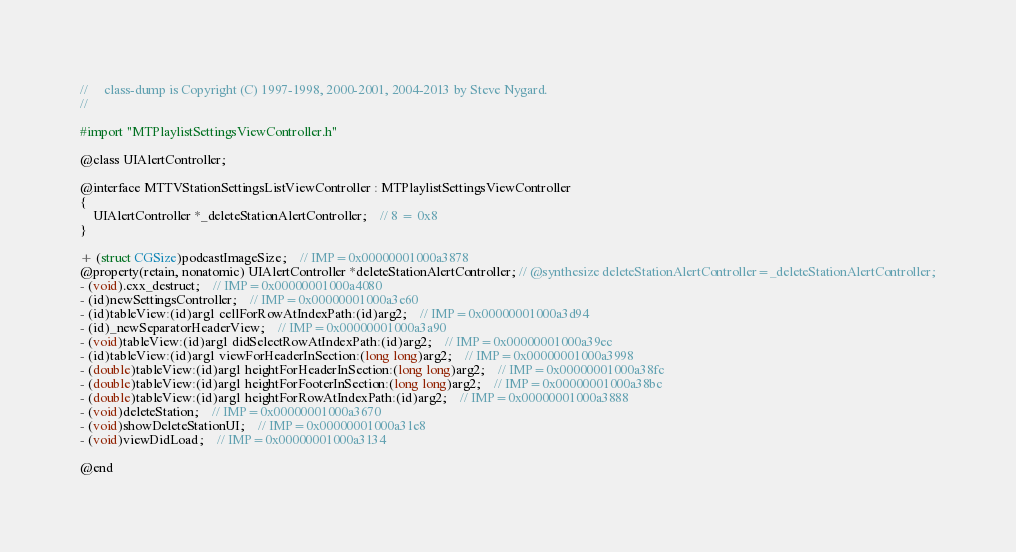<code> <loc_0><loc_0><loc_500><loc_500><_C_>//     class-dump is Copyright (C) 1997-1998, 2000-2001, 2004-2013 by Steve Nygard.
//

#import "MTPlaylistSettingsViewController.h"

@class UIAlertController;

@interface MTTVStationSettingsListViewController : MTPlaylistSettingsViewController
{
    UIAlertController *_deleteStationAlertController;	// 8 = 0x8
}

+ (struct CGSize)podcastImageSize;	// IMP=0x00000001000a3878
@property(retain, nonatomic) UIAlertController *deleteStationAlertController; // @synthesize deleteStationAlertController=_deleteStationAlertController;
- (void).cxx_destruct;	// IMP=0x00000001000a4080
- (id)newSettingsController;	// IMP=0x00000001000a3e60
- (id)tableView:(id)arg1 cellForRowAtIndexPath:(id)arg2;	// IMP=0x00000001000a3d94
- (id)_newSeparatorHeaderView;	// IMP=0x00000001000a3a90
- (void)tableView:(id)arg1 didSelectRowAtIndexPath:(id)arg2;	// IMP=0x00000001000a39ec
- (id)tableView:(id)arg1 viewForHeaderInSection:(long long)arg2;	// IMP=0x00000001000a3998
- (double)tableView:(id)arg1 heightForHeaderInSection:(long long)arg2;	// IMP=0x00000001000a38fc
- (double)tableView:(id)arg1 heightForFooterInSection:(long long)arg2;	// IMP=0x00000001000a38bc
- (double)tableView:(id)arg1 heightForRowAtIndexPath:(id)arg2;	// IMP=0x00000001000a3888
- (void)deleteStation;	// IMP=0x00000001000a3670
- (void)showDeleteStationUI;	// IMP=0x00000001000a31e8
- (void)viewDidLoad;	// IMP=0x00000001000a3134

@end

</code> 